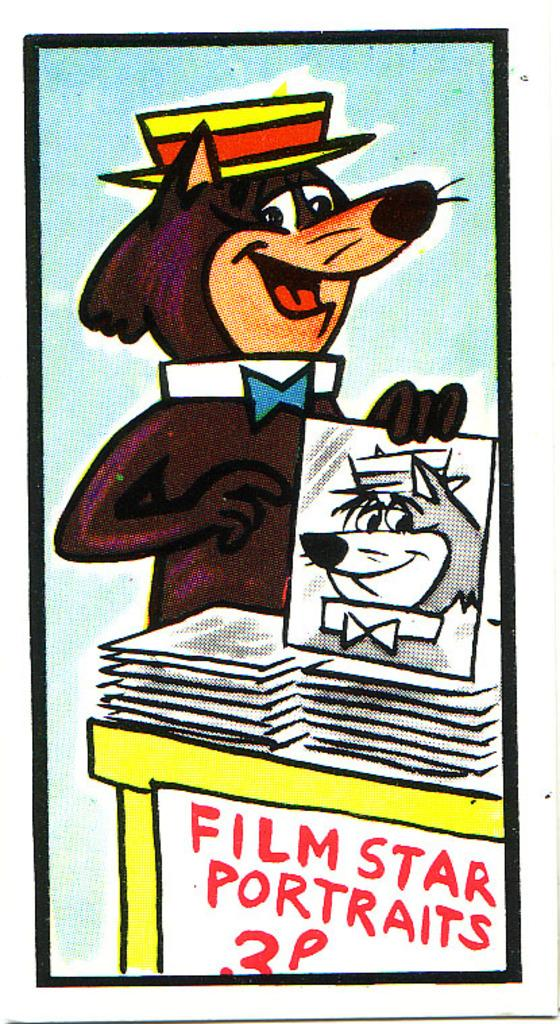Provide a one-sentence caption for the provided image. A cartoon animal is trying to sell pictures of himself for 3 p. 